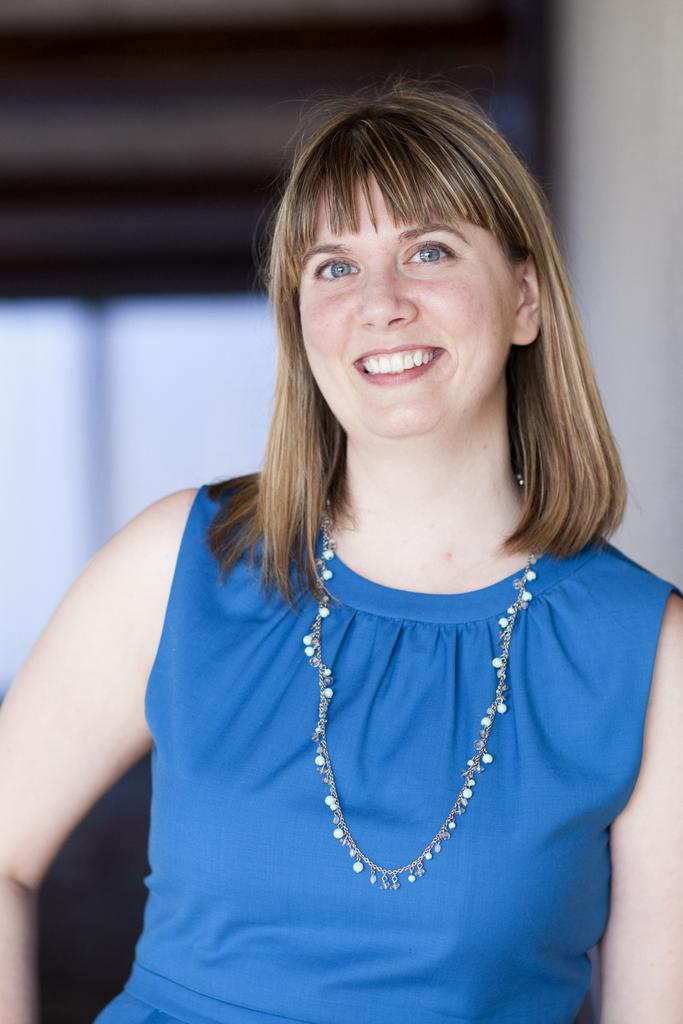Who is the main subject in the image? There is a woman in the image. What is the woman wearing? The woman is wearing a blue dress and a neck chain. What expression does the woman have? The woman is smiling. How would you describe the background of the image? The background of the image is blurred. How many stars can be seen in the woman's eyes in the image? There are no stars visible in the woman's eyes in the image. Are there any boys present in the image? There is no mention of boys in the provided facts, and therefore no boys are present in the image. 